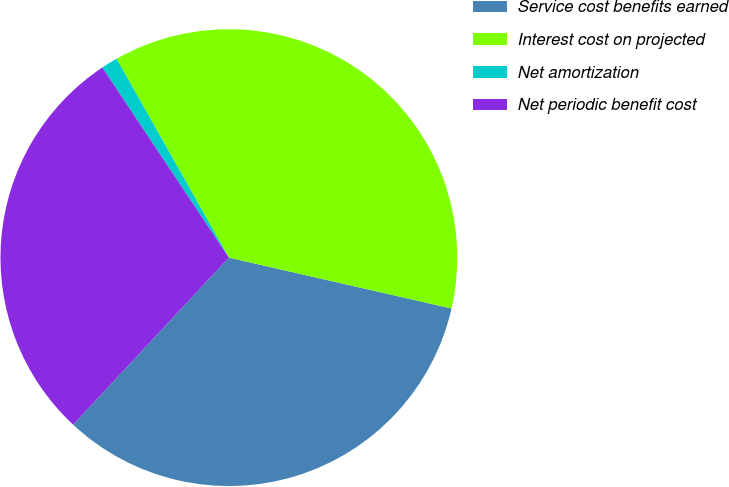Convert chart. <chart><loc_0><loc_0><loc_500><loc_500><pie_chart><fcel>Service cost benefits earned<fcel>Interest cost on projected<fcel>Net amortization<fcel>Net periodic benefit cost<nl><fcel>33.37%<fcel>36.76%<fcel>1.16%<fcel>28.71%<nl></chart> 